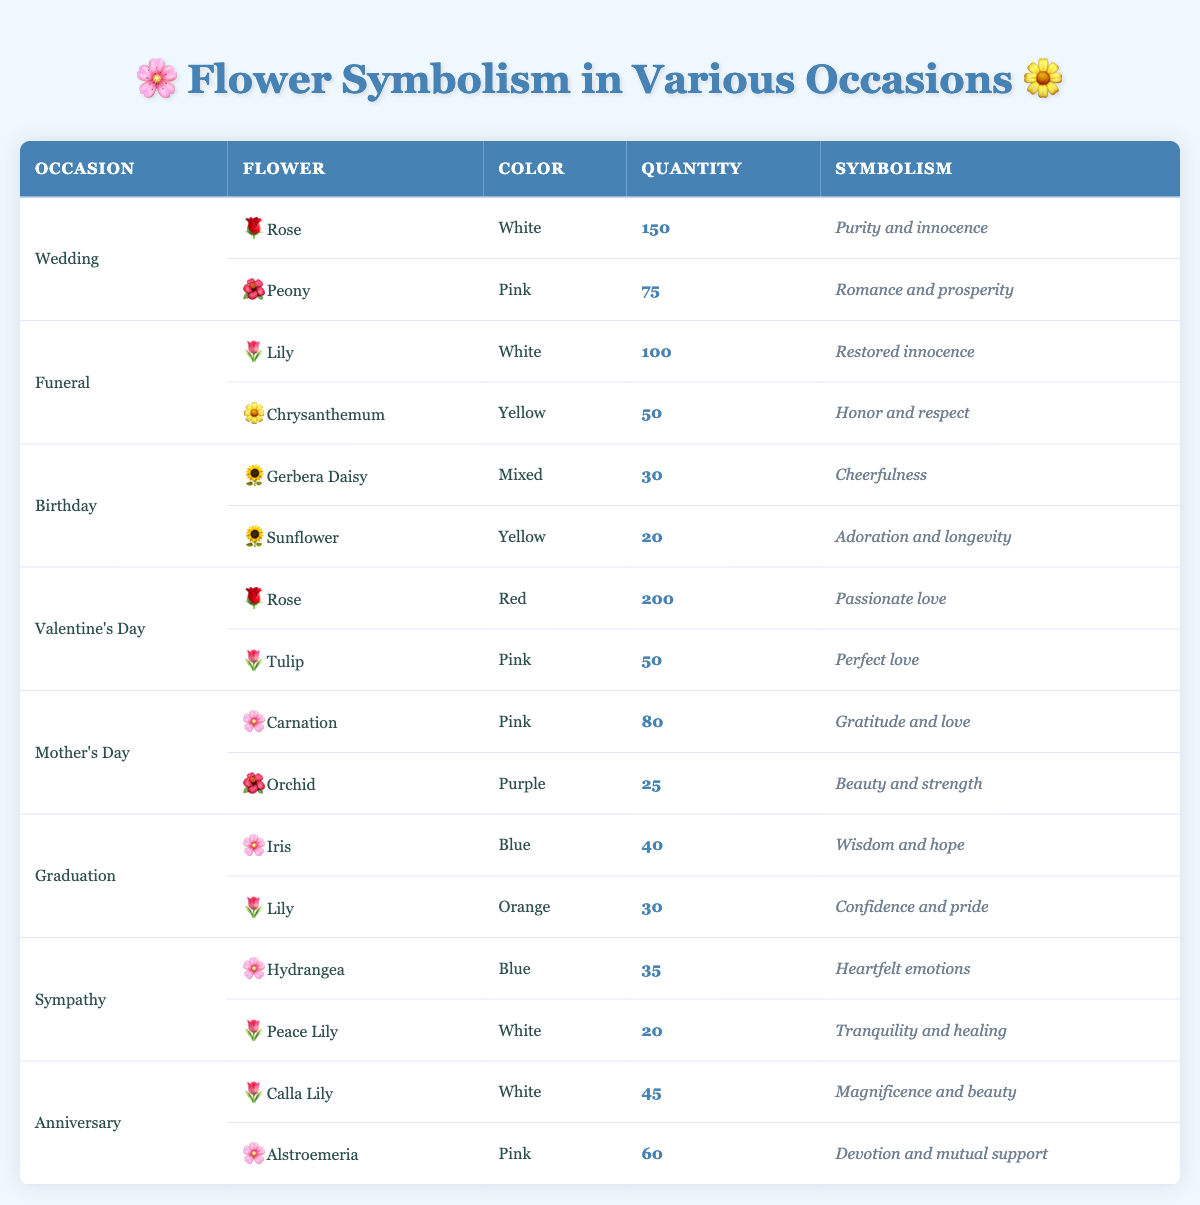What flower is most popular for Valentine's Day? The table shows two flowers listed for Valentine's Day: Rose (Red) with a quantity of 200 and Tulip (Pink) with a quantity of 50. The Rose has the highest quantity, indicating it is the most popular flower for this occasion.
Answer: Rose How many different types of flowers are listed for Mother's Day? The table shows two entries under Mother's Day: Carnation (Pink) and Orchid (Purple), meaning there are 2 different types of flowers for this occasion.
Answer: 2 What is the total quantity of flowers used for funerals? For funerals, Lily (White) has a quantity of 100 and Chrysanthemum (Yellow) has a quantity of 50. Adding these together gives a total of 100 + 50 = 150.
Answer: 150 Is the Gerbera Daisy the most popular flower for birthdays? The table displays two flowers for birthdays. Gerbera Daisy has a quantity of 30, while Sunflower has a quantity of 20. Since 30 is greater than 20, the Gerbera Daisy is the most popular flower for birthdays.
Answer: Yes What is the combined quantity of flowers for both anniversaries? The table shows two flowers for anniversaries: Calla Lily (White) with a quantity of 45 and Alstroemeria (Pink) with a quantity of 60. Adding these amounts gives 45 + 60 = 105.
Answer: 105 Which flower symbolizes confidence and pride, and for what occasion is it used? The table indicates that Lily (Orange) symbolizes confidence and pride, and it is listed under the Graduation occasion, confirming the flower's dual significance.
Answer: Lily (Orange) for Graduation How many flowers used for graduation are blue in color? Looking at the graduation entries, Iris (Blue) has a quantity of 40, making it the only blue flower in this category. Thus, there is just one blue flower.
Answer: 1 What is the average quantity of flowers used for Valentine’s Day arrangements? For Valentine's Day, the quantities listed are Rose (200) and Tulip (50). To find the average, first sum the quantities: 200 + 50 = 250. There are 2 flowers, so the average is 250 / 2 = 125.
Answer: 125 Which occasion has the highest total quantity of flowers used? Wedding has 150 (Rose) + 75 (Peony) = 225; Valentine's Day has 200 (Rose) + 50 (Tulip) = 250; Funeral has 100 (Lily) + 50 (Chrysanthemum) = 150; Birthday has 30 (Gerbera Daisy) + 20 (Sunflower) = 50; Mother's Day has 80 (Carnation) + 25 (Orchid) = 105; Graduation has 40 (Iris) + 30 (Lily) = 70; Sympathy has 35 (Hydrangea) + 20 (Peace Lily) = 55; and Anniversary has 45 (Calla Lily) + 60 (Alstroemeria) = 105. The highest quantity is for Valentine's Day with 250.
Answer: Valentine's Day 